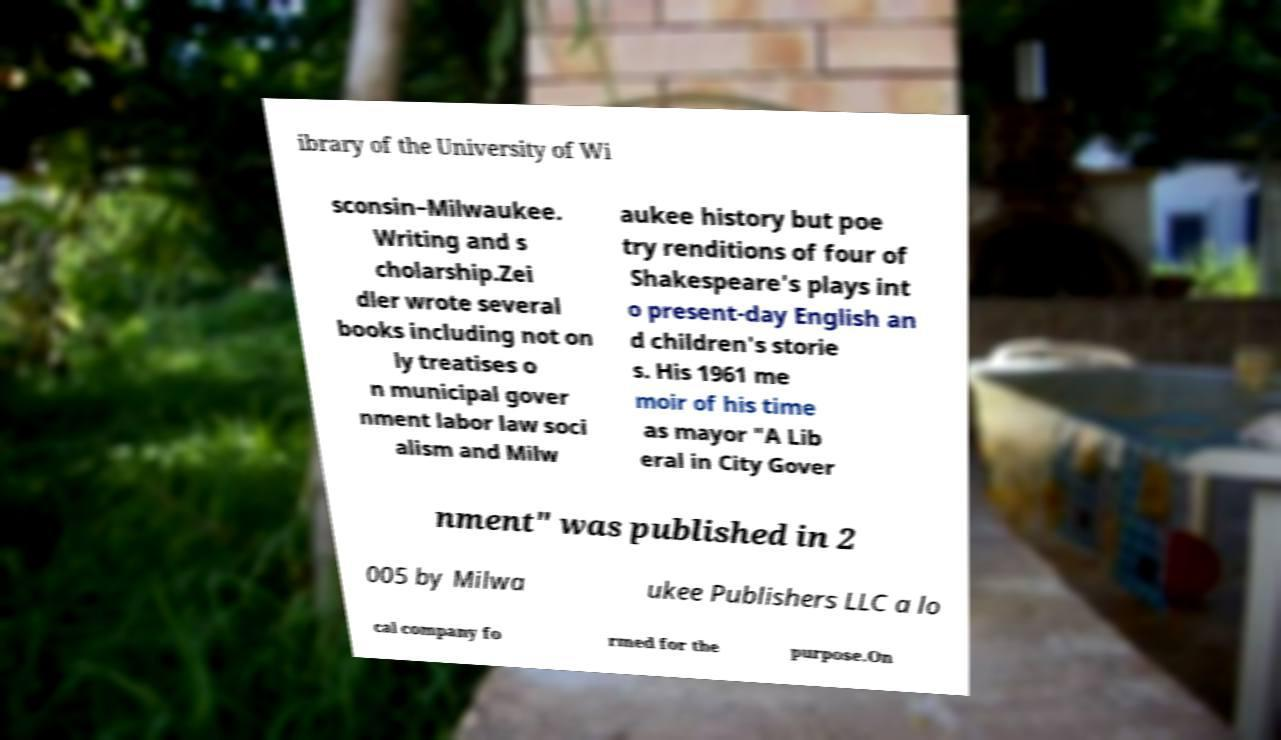For documentation purposes, I need the text within this image transcribed. Could you provide that? ibrary of the University of Wi sconsin–Milwaukee. Writing and s cholarship.Zei dler wrote several books including not on ly treatises o n municipal gover nment labor law soci alism and Milw aukee history but poe try renditions of four of Shakespeare's plays int o present-day English an d children's storie s. His 1961 me moir of his time as mayor "A Lib eral in City Gover nment" was published in 2 005 by Milwa ukee Publishers LLC a lo cal company fo rmed for the purpose.On 